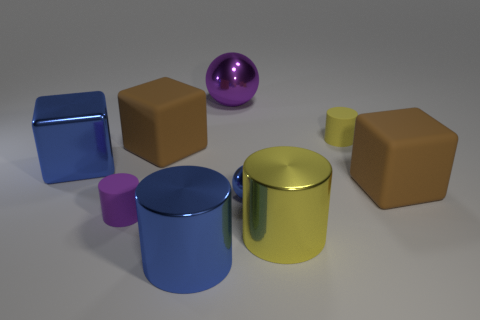There is a yellow metal cylinder; are there any tiny yellow things in front of it?
Give a very brief answer. No. What material is the purple cylinder?
Provide a short and direct response. Rubber. Is the color of the matte cylinder left of the big sphere the same as the large sphere?
Provide a short and direct response. Yes. The big object that is the same shape as the small blue metal object is what color?
Offer a very short reply. Purple. There is a small cylinder that is left of the tiny ball; what material is it?
Your response must be concise. Rubber. The tiny ball has what color?
Give a very brief answer. Blue. Do the cylinder behind the blue metal block and the small blue ball have the same size?
Make the answer very short. Yes. What material is the yellow cylinder that is in front of the shiny object that is on the left side of the brown thing left of the yellow shiny thing made of?
Your answer should be compact. Metal. Do the tiny object on the right side of the tiny blue sphere and the large cylinder right of the big shiny sphere have the same color?
Make the answer very short. Yes. What is the material of the small thing that is behind the big brown matte object left of the big metallic sphere?
Make the answer very short. Rubber. 